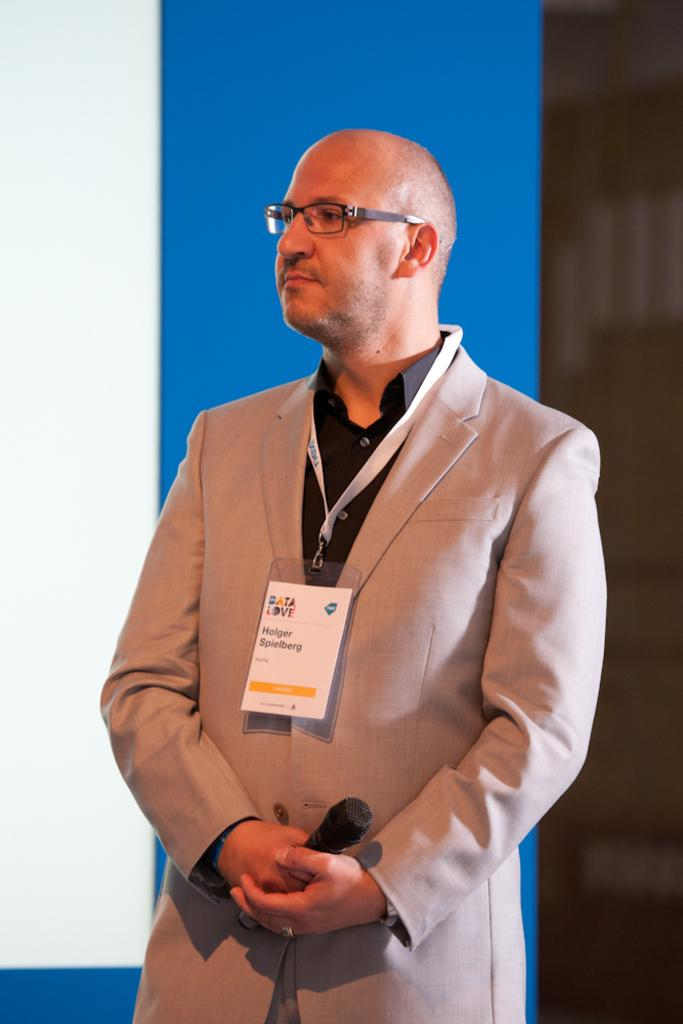Where was the image taken? The image is taken indoors. What can be seen in the background of the image? There is a wall in the background of the image. Who is the main subject in the image? A man is standing in the middle of the image. What is the man holding in his hands? The man is holding a mic in his hands. Can you see a crow sitting on a nest near the mailbox in the image? There is no mailbox, crow, or nest present in the image. 